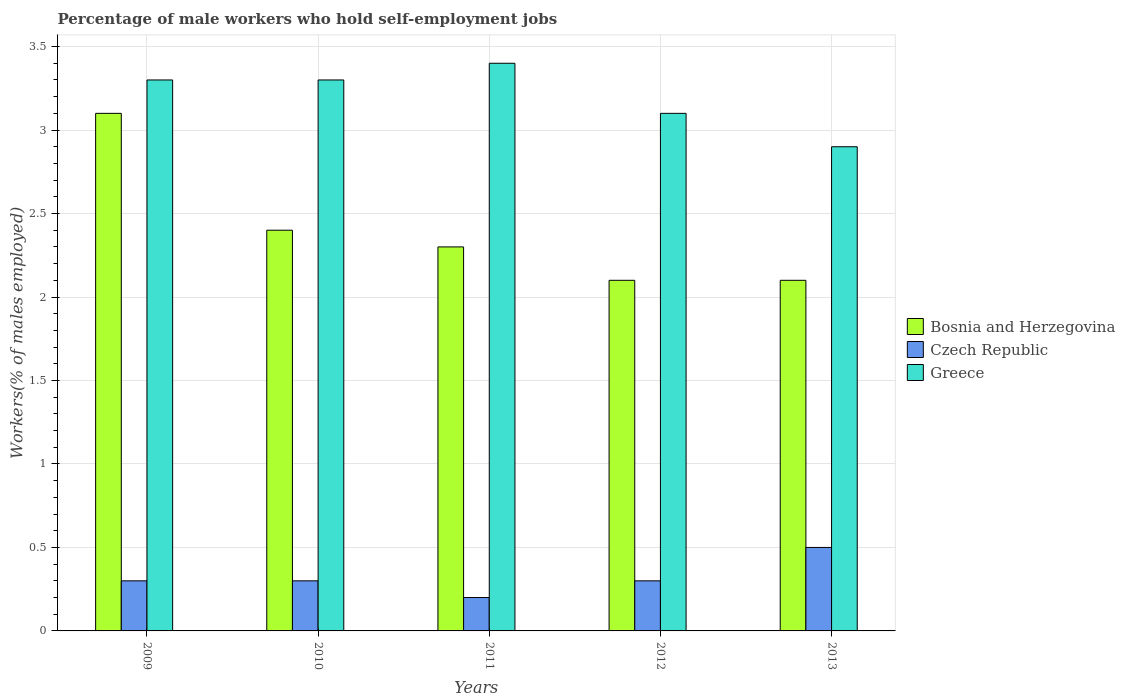How many different coloured bars are there?
Make the answer very short. 3. How many groups of bars are there?
Provide a succinct answer. 5. Are the number of bars per tick equal to the number of legend labels?
Offer a very short reply. Yes. Are the number of bars on each tick of the X-axis equal?
Make the answer very short. Yes. How many bars are there on the 3rd tick from the right?
Your answer should be very brief. 3. What is the label of the 5th group of bars from the left?
Your answer should be very brief. 2013. What is the percentage of self-employed male workers in Greece in 2009?
Offer a very short reply. 3.3. Across all years, what is the maximum percentage of self-employed male workers in Bosnia and Herzegovina?
Give a very brief answer. 3.1. Across all years, what is the minimum percentage of self-employed male workers in Czech Republic?
Your response must be concise. 0.2. What is the total percentage of self-employed male workers in Bosnia and Herzegovina in the graph?
Make the answer very short. 12. What is the difference between the percentage of self-employed male workers in Bosnia and Herzegovina in 2009 and that in 2013?
Offer a terse response. 1. What is the difference between the percentage of self-employed male workers in Czech Republic in 2010 and the percentage of self-employed male workers in Greece in 2013?
Ensure brevity in your answer.  -2.6. What is the average percentage of self-employed male workers in Czech Republic per year?
Provide a succinct answer. 0.32. In the year 2013, what is the difference between the percentage of self-employed male workers in Greece and percentage of self-employed male workers in Bosnia and Herzegovina?
Provide a succinct answer. 0.8. What is the ratio of the percentage of self-employed male workers in Greece in 2011 to that in 2012?
Give a very brief answer. 1.1. Is the percentage of self-employed male workers in Greece in 2010 less than that in 2013?
Offer a terse response. No. What is the difference between the highest and the second highest percentage of self-employed male workers in Greece?
Give a very brief answer. 0.1. What is the difference between the highest and the lowest percentage of self-employed male workers in Czech Republic?
Offer a very short reply. 0.3. In how many years, is the percentage of self-employed male workers in Czech Republic greater than the average percentage of self-employed male workers in Czech Republic taken over all years?
Provide a short and direct response. 1. What does the 1st bar from the left in 2013 represents?
Offer a terse response. Bosnia and Herzegovina. How many years are there in the graph?
Offer a terse response. 5. What is the difference between two consecutive major ticks on the Y-axis?
Your answer should be compact. 0.5. Are the values on the major ticks of Y-axis written in scientific E-notation?
Provide a succinct answer. No. Does the graph contain grids?
Your response must be concise. Yes. How many legend labels are there?
Give a very brief answer. 3. What is the title of the graph?
Your answer should be compact. Percentage of male workers who hold self-employment jobs. Does "Croatia" appear as one of the legend labels in the graph?
Provide a short and direct response. No. What is the label or title of the X-axis?
Provide a succinct answer. Years. What is the label or title of the Y-axis?
Give a very brief answer. Workers(% of males employed). What is the Workers(% of males employed) in Bosnia and Herzegovina in 2009?
Your answer should be compact. 3.1. What is the Workers(% of males employed) in Czech Republic in 2009?
Offer a very short reply. 0.3. What is the Workers(% of males employed) of Greece in 2009?
Your answer should be compact. 3.3. What is the Workers(% of males employed) of Bosnia and Herzegovina in 2010?
Your response must be concise. 2.4. What is the Workers(% of males employed) in Czech Republic in 2010?
Provide a short and direct response. 0.3. What is the Workers(% of males employed) of Greece in 2010?
Give a very brief answer. 3.3. What is the Workers(% of males employed) of Bosnia and Herzegovina in 2011?
Your response must be concise. 2.3. What is the Workers(% of males employed) of Czech Republic in 2011?
Your response must be concise. 0.2. What is the Workers(% of males employed) of Greece in 2011?
Ensure brevity in your answer.  3.4. What is the Workers(% of males employed) in Bosnia and Herzegovina in 2012?
Offer a terse response. 2.1. What is the Workers(% of males employed) in Czech Republic in 2012?
Ensure brevity in your answer.  0.3. What is the Workers(% of males employed) in Greece in 2012?
Give a very brief answer. 3.1. What is the Workers(% of males employed) in Bosnia and Herzegovina in 2013?
Your answer should be compact. 2.1. What is the Workers(% of males employed) of Greece in 2013?
Make the answer very short. 2.9. Across all years, what is the maximum Workers(% of males employed) of Bosnia and Herzegovina?
Provide a short and direct response. 3.1. Across all years, what is the maximum Workers(% of males employed) in Greece?
Your answer should be compact. 3.4. Across all years, what is the minimum Workers(% of males employed) in Bosnia and Herzegovina?
Offer a terse response. 2.1. Across all years, what is the minimum Workers(% of males employed) of Czech Republic?
Your answer should be very brief. 0.2. Across all years, what is the minimum Workers(% of males employed) in Greece?
Give a very brief answer. 2.9. What is the total Workers(% of males employed) in Bosnia and Herzegovina in the graph?
Make the answer very short. 12. What is the difference between the Workers(% of males employed) of Czech Republic in 2009 and that in 2010?
Provide a succinct answer. 0. What is the difference between the Workers(% of males employed) of Bosnia and Herzegovina in 2009 and that in 2011?
Offer a very short reply. 0.8. What is the difference between the Workers(% of males employed) in Bosnia and Herzegovina in 2009 and that in 2012?
Your answer should be very brief. 1. What is the difference between the Workers(% of males employed) of Greece in 2009 and that in 2012?
Offer a very short reply. 0.2. What is the difference between the Workers(% of males employed) of Bosnia and Herzegovina in 2009 and that in 2013?
Provide a short and direct response. 1. What is the difference between the Workers(% of males employed) in Czech Republic in 2009 and that in 2013?
Your answer should be compact. -0.2. What is the difference between the Workers(% of males employed) in Bosnia and Herzegovina in 2010 and that in 2011?
Make the answer very short. 0.1. What is the difference between the Workers(% of males employed) in Bosnia and Herzegovina in 2010 and that in 2012?
Your response must be concise. 0.3. What is the difference between the Workers(% of males employed) of Czech Republic in 2010 and that in 2013?
Your answer should be very brief. -0.2. What is the difference between the Workers(% of males employed) of Greece in 2010 and that in 2013?
Provide a short and direct response. 0.4. What is the difference between the Workers(% of males employed) in Czech Republic in 2011 and that in 2012?
Your response must be concise. -0.1. What is the difference between the Workers(% of males employed) of Czech Republic in 2012 and that in 2013?
Your response must be concise. -0.2. What is the difference between the Workers(% of males employed) of Bosnia and Herzegovina in 2009 and the Workers(% of males employed) of Czech Republic in 2011?
Keep it short and to the point. 2.9. What is the difference between the Workers(% of males employed) of Czech Republic in 2009 and the Workers(% of males employed) of Greece in 2011?
Your response must be concise. -3.1. What is the difference between the Workers(% of males employed) of Bosnia and Herzegovina in 2009 and the Workers(% of males employed) of Czech Republic in 2012?
Provide a succinct answer. 2.8. What is the difference between the Workers(% of males employed) in Bosnia and Herzegovina in 2009 and the Workers(% of males employed) in Greece in 2012?
Keep it short and to the point. 0. What is the difference between the Workers(% of males employed) in Czech Republic in 2009 and the Workers(% of males employed) in Greece in 2012?
Your answer should be compact. -2.8. What is the difference between the Workers(% of males employed) in Bosnia and Herzegovina in 2009 and the Workers(% of males employed) in Greece in 2013?
Give a very brief answer. 0.2. What is the difference between the Workers(% of males employed) of Czech Republic in 2009 and the Workers(% of males employed) of Greece in 2013?
Your answer should be very brief. -2.6. What is the difference between the Workers(% of males employed) in Bosnia and Herzegovina in 2010 and the Workers(% of males employed) in Greece in 2011?
Your answer should be very brief. -1. What is the difference between the Workers(% of males employed) in Bosnia and Herzegovina in 2010 and the Workers(% of males employed) in Czech Republic in 2012?
Your response must be concise. 2.1. What is the difference between the Workers(% of males employed) in Czech Republic in 2010 and the Workers(% of males employed) in Greece in 2012?
Your answer should be very brief. -2.8. What is the difference between the Workers(% of males employed) of Bosnia and Herzegovina in 2010 and the Workers(% of males employed) of Czech Republic in 2013?
Your response must be concise. 1.9. What is the difference between the Workers(% of males employed) of Czech Republic in 2010 and the Workers(% of males employed) of Greece in 2013?
Ensure brevity in your answer.  -2.6. What is the difference between the Workers(% of males employed) of Czech Republic in 2011 and the Workers(% of males employed) of Greece in 2012?
Offer a very short reply. -2.9. What is the difference between the Workers(% of males employed) in Bosnia and Herzegovina in 2012 and the Workers(% of males employed) in Czech Republic in 2013?
Offer a terse response. 1.6. What is the difference between the Workers(% of males employed) in Bosnia and Herzegovina in 2012 and the Workers(% of males employed) in Greece in 2013?
Your response must be concise. -0.8. What is the average Workers(% of males employed) of Czech Republic per year?
Your answer should be compact. 0.32. What is the average Workers(% of males employed) in Greece per year?
Provide a succinct answer. 3.2. In the year 2009, what is the difference between the Workers(% of males employed) in Bosnia and Herzegovina and Workers(% of males employed) in Czech Republic?
Offer a very short reply. 2.8. In the year 2009, what is the difference between the Workers(% of males employed) of Bosnia and Herzegovina and Workers(% of males employed) of Greece?
Your answer should be compact. -0.2. In the year 2009, what is the difference between the Workers(% of males employed) in Czech Republic and Workers(% of males employed) in Greece?
Provide a short and direct response. -3. In the year 2010, what is the difference between the Workers(% of males employed) of Bosnia and Herzegovina and Workers(% of males employed) of Czech Republic?
Provide a succinct answer. 2.1. In the year 2011, what is the difference between the Workers(% of males employed) in Bosnia and Herzegovina and Workers(% of males employed) in Czech Republic?
Provide a succinct answer. 2.1. In the year 2012, what is the difference between the Workers(% of males employed) in Bosnia and Herzegovina and Workers(% of males employed) in Greece?
Your answer should be compact. -1. In the year 2013, what is the difference between the Workers(% of males employed) of Bosnia and Herzegovina and Workers(% of males employed) of Greece?
Your response must be concise. -0.8. In the year 2013, what is the difference between the Workers(% of males employed) in Czech Republic and Workers(% of males employed) in Greece?
Your response must be concise. -2.4. What is the ratio of the Workers(% of males employed) of Bosnia and Herzegovina in 2009 to that in 2010?
Your answer should be compact. 1.29. What is the ratio of the Workers(% of males employed) in Czech Republic in 2009 to that in 2010?
Your answer should be compact. 1. What is the ratio of the Workers(% of males employed) in Greece in 2009 to that in 2010?
Your answer should be compact. 1. What is the ratio of the Workers(% of males employed) of Bosnia and Herzegovina in 2009 to that in 2011?
Ensure brevity in your answer.  1.35. What is the ratio of the Workers(% of males employed) in Greece in 2009 to that in 2011?
Give a very brief answer. 0.97. What is the ratio of the Workers(% of males employed) in Bosnia and Herzegovina in 2009 to that in 2012?
Provide a succinct answer. 1.48. What is the ratio of the Workers(% of males employed) of Czech Republic in 2009 to that in 2012?
Provide a short and direct response. 1. What is the ratio of the Workers(% of males employed) of Greece in 2009 to that in 2012?
Your response must be concise. 1.06. What is the ratio of the Workers(% of males employed) in Bosnia and Herzegovina in 2009 to that in 2013?
Provide a succinct answer. 1.48. What is the ratio of the Workers(% of males employed) in Greece in 2009 to that in 2013?
Keep it short and to the point. 1.14. What is the ratio of the Workers(% of males employed) in Bosnia and Herzegovina in 2010 to that in 2011?
Ensure brevity in your answer.  1.04. What is the ratio of the Workers(% of males employed) in Czech Republic in 2010 to that in 2011?
Provide a short and direct response. 1.5. What is the ratio of the Workers(% of males employed) in Greece in 2010 to that in 2011?
Ensure brevity in your answer.  0.97. What is the ratio of the Workers(% of males employed) of Bosnia and Herzegovina in 2010 to that in 2012?
Keep it short and to the point. 1.14. What is the ratio of the Workers(% of males employed) of Czech Republic in 2010 to that in 2012?
Keep it short and to the point. 1. What is the ratio of the Workers(% of males employed) of Greece in 2010 to that in 2012?
Offer a very short reply. 1.06. What is the ratio of the Workers(% of males employed) in Bosnia and Herzegovina in 2010 to that in 2013?
Offer a terse response. 1.14. What is the ratio of the Workers(% of males employed) of Greece in 2010 to that in 2013?
Provide a short and direct response. 1.14. What is the ratio of the Workers(% of males employed) of Bosnia and Herzegovina in 2011 to that in 2012?
Give a very brief answer. 1.1. What is the ratio of the Workers(% of males employed) of Greece in 2011 to that in 2012?
Make the answer very short. 1.1. What is the ratio of the Workers(% of males employed) of Bosnia and Herzegovina in 2011 to that in 2013?
Provide a short and direct response. 1.1. What is the ratio of the Workers(% of males employed) of Czech Republic in 2011 to that in 2013?
Give a very brief answer. 0.4. What is the ratio of the Workers(% of males employed) of Greece in 2011 to that in 2013?
Your response must be concise. 1.17. What is the ratio of the Workers(% of males employed) in Bosnia and Herzegovina in 2012 to that in 2013?
Provide a succinct answer. 1. What is the ratio of the Workers(% of males employed) in Greece in 2012 to that in 2013?
Give a very brief answer. 1.07. What is the difference between the highest and the second highest Workers(% of males employed) of Greece?
Offer a terse response. 0.1. What is the difference between the highest and the lowest Workers(% of males employed) of Bosnia and Herzegovina?
Your answer should be compact. 1. 